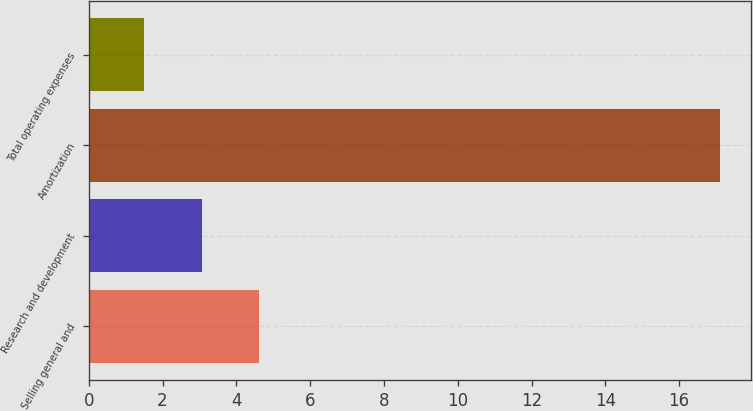Convert chart. <chart><loc_0><loc_0><loc_500><loc_500><bar_chart><fcel>Selling general and<fcel>Research and development<fcel>Amortization<fcel>Total operating expenses<nl><fcel>4.62<fcel>3.06<fcel>17.1<fcel>1.5<nl></chart> 